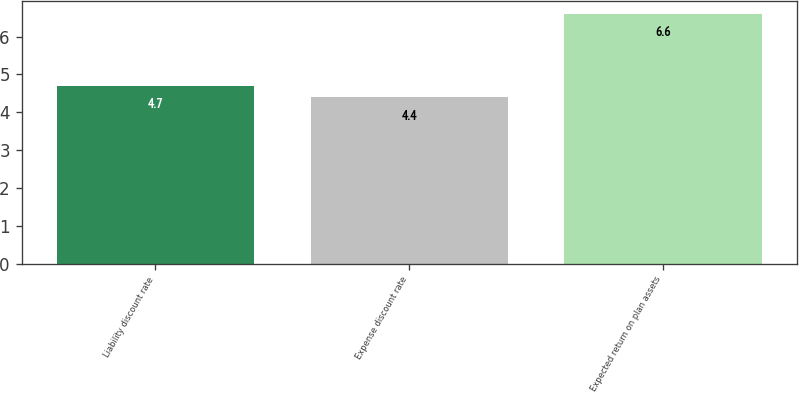Convert chart. <chart><loc_0><loc_0><loc_500><loc_500><bar_chart><fcel>Liability discount rate<fcel>Expense discount rate<fcel>Expected return on plan assets<nl><fcel>4.7<fcel>4.4<fcel>6.6<nl></chart> 